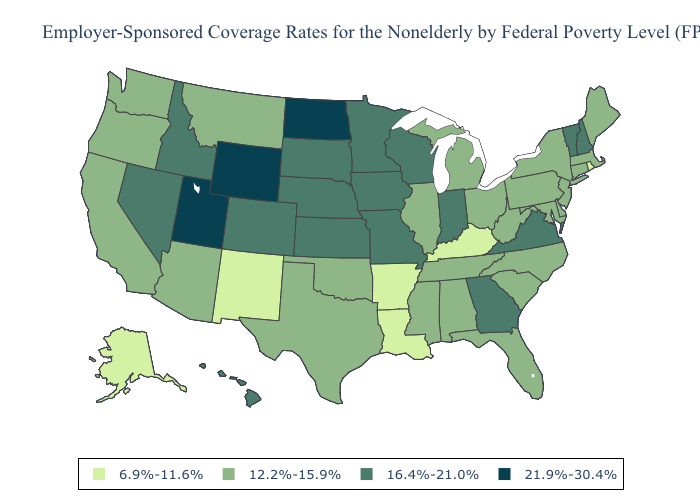What is the lowest value in the USA?
Write a very short answer. 6.9%-11.6%. Among the states that border Minnesota , which have the highest value?
Give a very brief answer. North Dakota. Name the states that have a value in the range 16.4%-21.0%?
Answer briefly. Colorado, Georgia, Hawaii, Idaho, Indiana, Iowa, Kansas, Minnesota, Missouri, Nebraska, Nevada, New Hampshire, South Dakota, Vermont, Virginia, Wisconsin. Name the states that have a value in the range 21.9%-30.4%?
Give a very brief answer. North Dakota, Utah, Wyoming. Does South Dakota have the lowest value in the USA?
Give a very brief answer. No. Which states have the highest value in the USA?
Quick response, please. North Dakota, Utah, Wyoming. Among the states that border Michigan , does Indiana have the highest value?
Quick response, please. Yes. What is the lowest value in the USA?
Keep it brief. 6.9%-11.6%. What is the lowest value in the USA?
Give a very brief answer. 6.9%-11.6%. What is the value of Arkansas?
Be succinct. 6.9%-11.6%. Does New Hampshire have a lower value than New York?
Answer briefly. No. What is the value of Kansas?
Write a very short answer. 16.4%-21.0%. Does the map have missing data?
Short answer required. No. Among the states that border New Mexico , does Utah have the lowest value?
Answer briefly. No. Among the states that border Texas , which have the highest value?
Answer briefly. Oklahoma. 